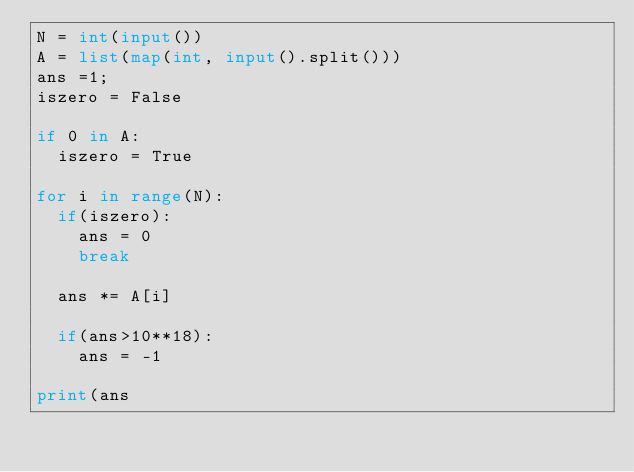Convert code to text. <code><loc_0><loc_0><loc_500><loc_500><_Python_>N = int(input())
A = list(map(int, input().split()))
ans =1;
iszero = False

if 0 in A:
  iszero = True

for i in range(N):
  if(iszero):
    ans = 0
    break
    
  ans *= A[i]
  
  if(ans>10**18):
    ans = -1

print(ans</code> 